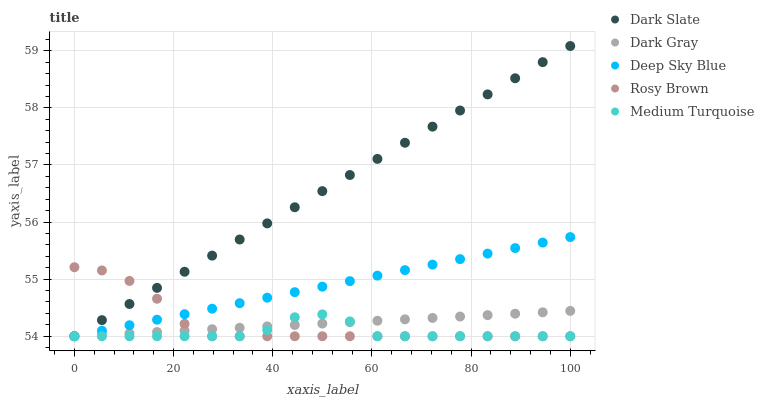Does Medium Turquoise have the minimum area under the curve?
Answer yes or no. Yes. Does Dark Slate have the maximum area under the curve?
Answer yes or no. Yes. Does Rosy Brown have the minimum area under the curve?
Answer yes or no. No. Does Rosy Brown have the maximum area under the curve?
Answer yes or no. No. Is Deep Sky Blue the smoothest?
Answer yes or no. Yes. Is Medium Turquoise the roughest?
Answer yes or no. Yes. Is Dark Slate the smoothest?
Answer yes or no. No. Is Dark Slate the roughest?
Answer yes or no. No. Does Dark Gray have the lowest value?
Answer yes or no. Yes. Does Dark Slate have the highest value?
Answer yes or no. Yes. Does Rosy Brown have the highest value?
Answer yes or no. No. Does Deep Sky Blue intersect Rosy Brown?
Answer yes or no. Yes. Is Deep Sky Blue less than Rosy Brown?
Answer yes or no. No. Is Deep Sky Blue greater than Rosy Brown?
Answer yes or no. No. 